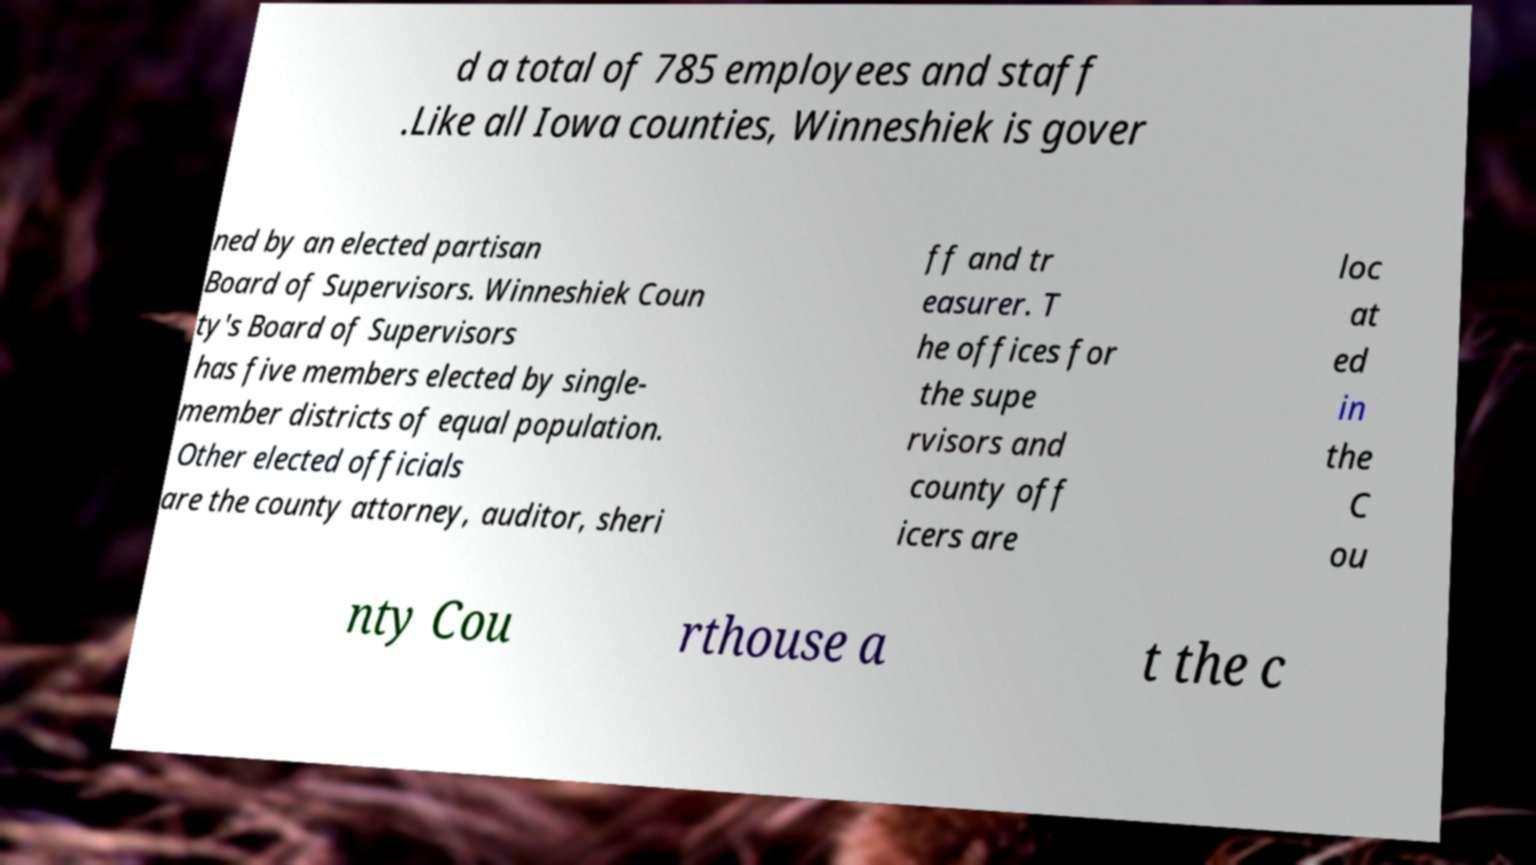There's text embedded in this image that I need extracted. Can you transcribe it verbatim? d a total of 785 employees and staff .Like all Iowa counties, Winneshiek is gover ned by an elected partisan Board of Supervisors. Winneshiek Coun ty's Board of Supervisors has five members elected by single- member districts of equal population. Other elected officials are the county attorney, auditor, sheri ff and tr easurer. T he offices for the supe rvisors and county off icers are loc at ed in the C ou nty Cou rthouse a t the c 